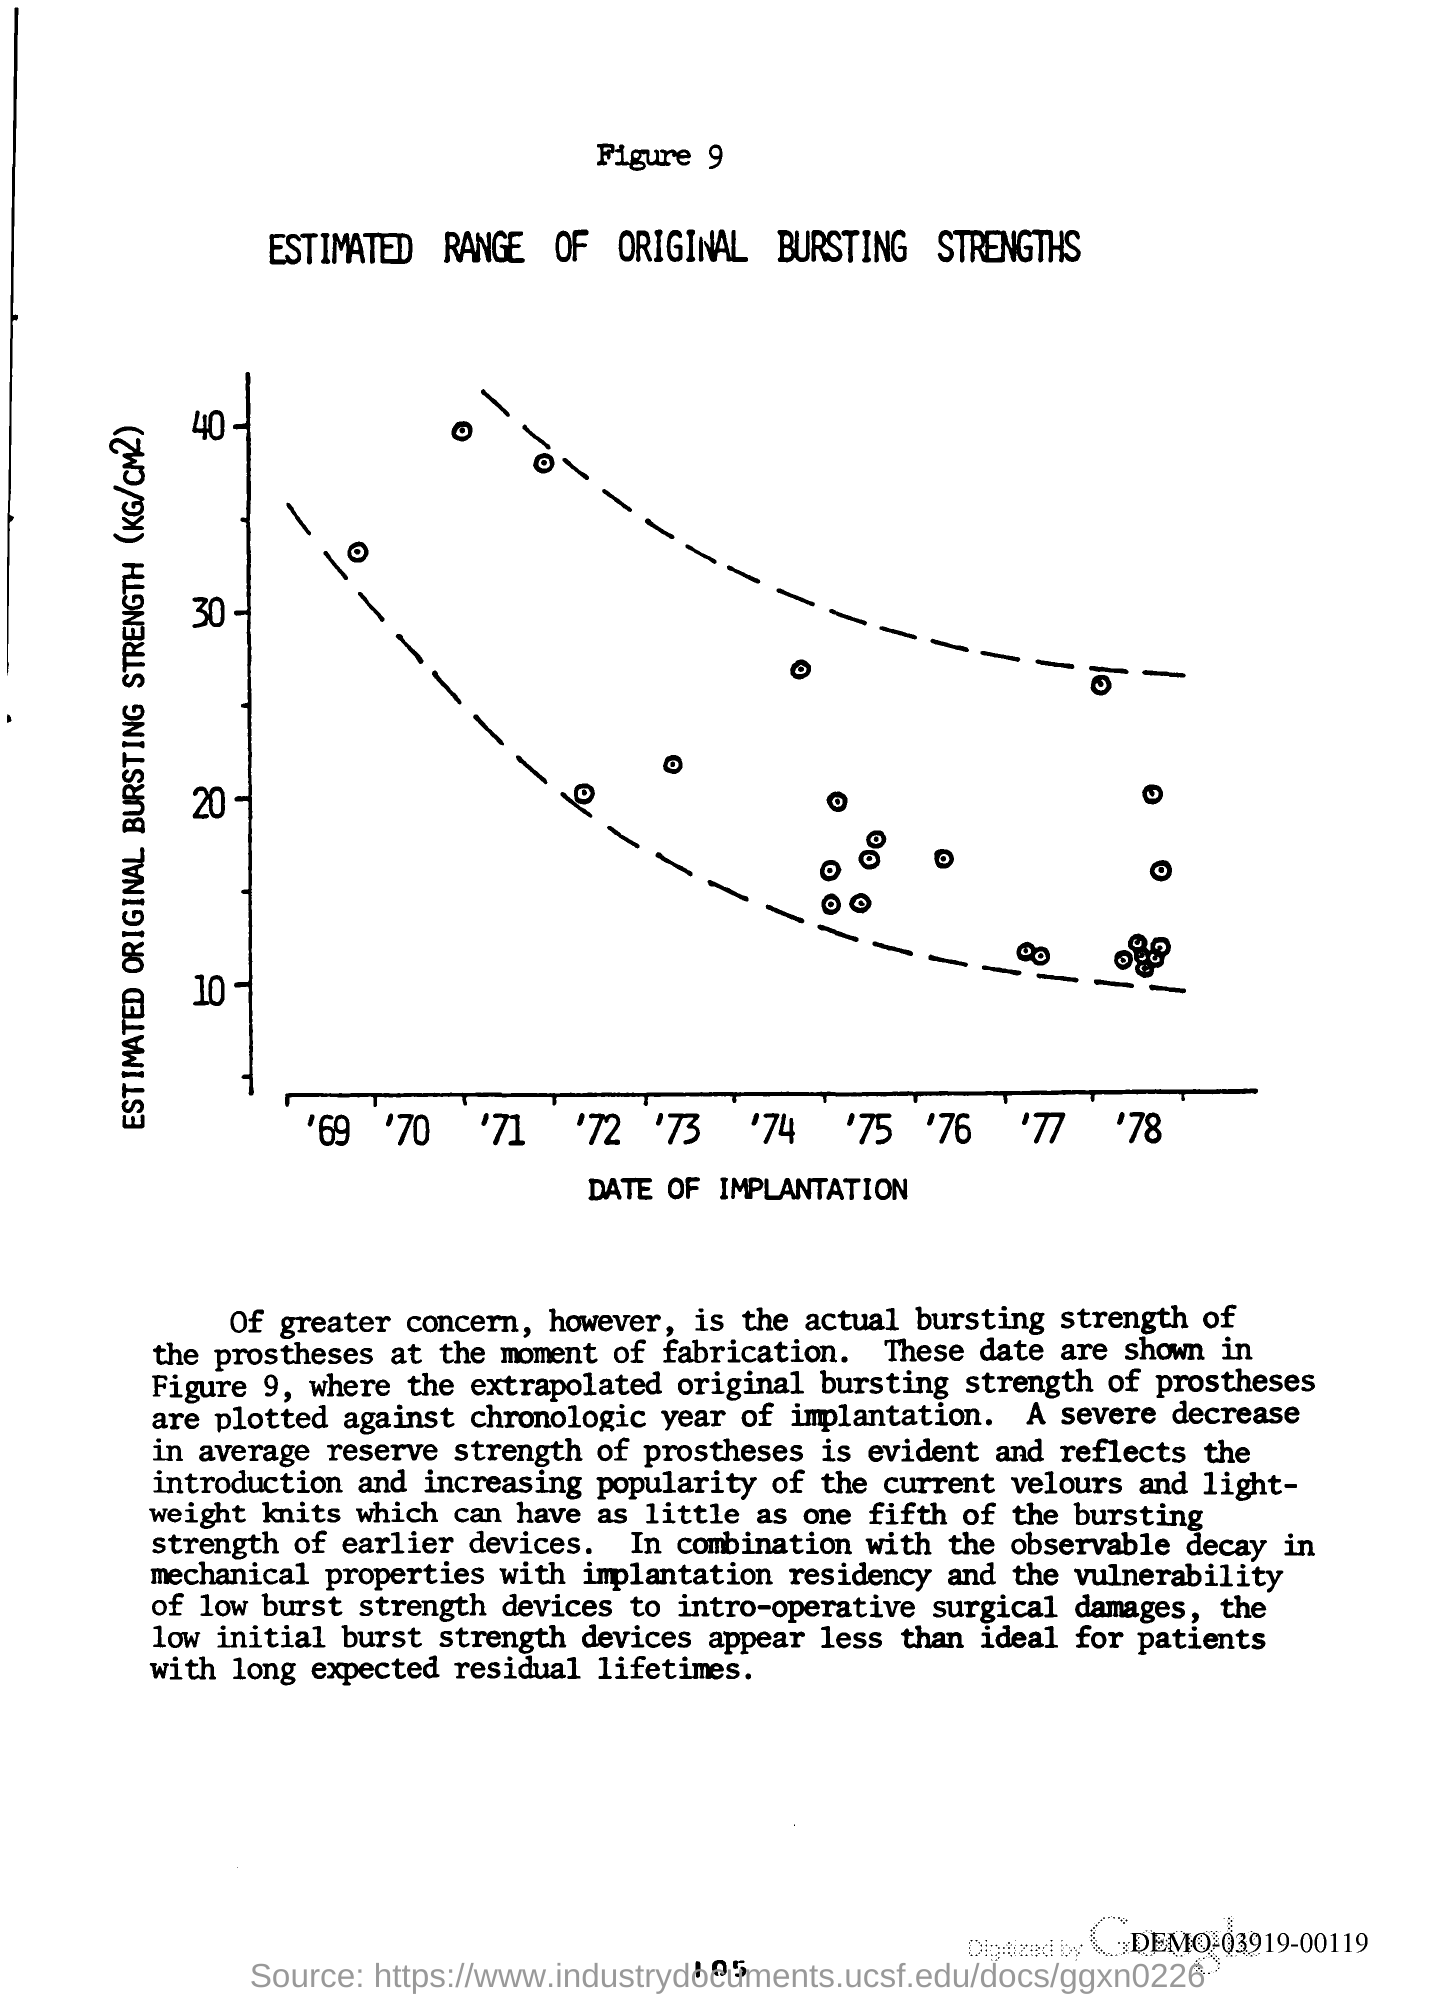What is the title of Figure 9?
Your answer should be compact. ESTIMATED RANGE OF ORIGINAL BURSTING STRENGTHS. What deos the x-axis of the graph represent?
Provide a short and direct response. DATE OF IMPLANTATION. What does y-axis of the graph represent?
Ensure brevity in your answer.  ESTIMATED ORIGINAL BURSTING STRENGTH (KG/CM2). 